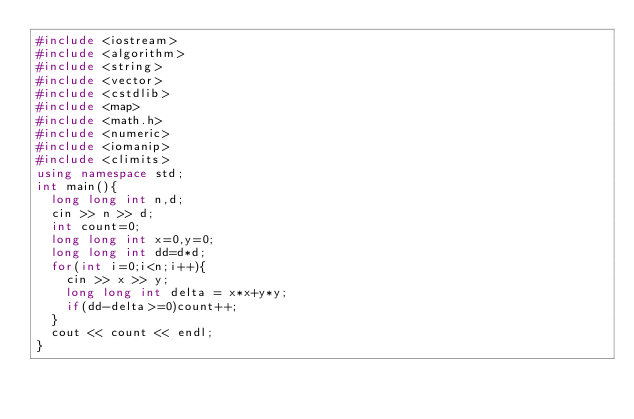Convert code to text. <code><loc_0><loc_0><loc_500><loc_500><_C++_>#include <iostream>
#include <algorithm>
#include <string>
#include <vector>
#include <cstdlib>
#include <map>
#include <math.h>
#include <numeric>
#include <iomanip>
#include <climits>
using namespace std;
int main(){
  long long int n,d;
  cin >> n >> d;
  int count=0;
  long long int x=0,y=0;
  long long int dd=d*d;
  for(int i=0;i<n;i++){
    cin >> x >> y;
    long long int delta = x*x+y*y;
    if(dd-delta>=0)count++;
  }
  cout << count << endl;
}</code> 